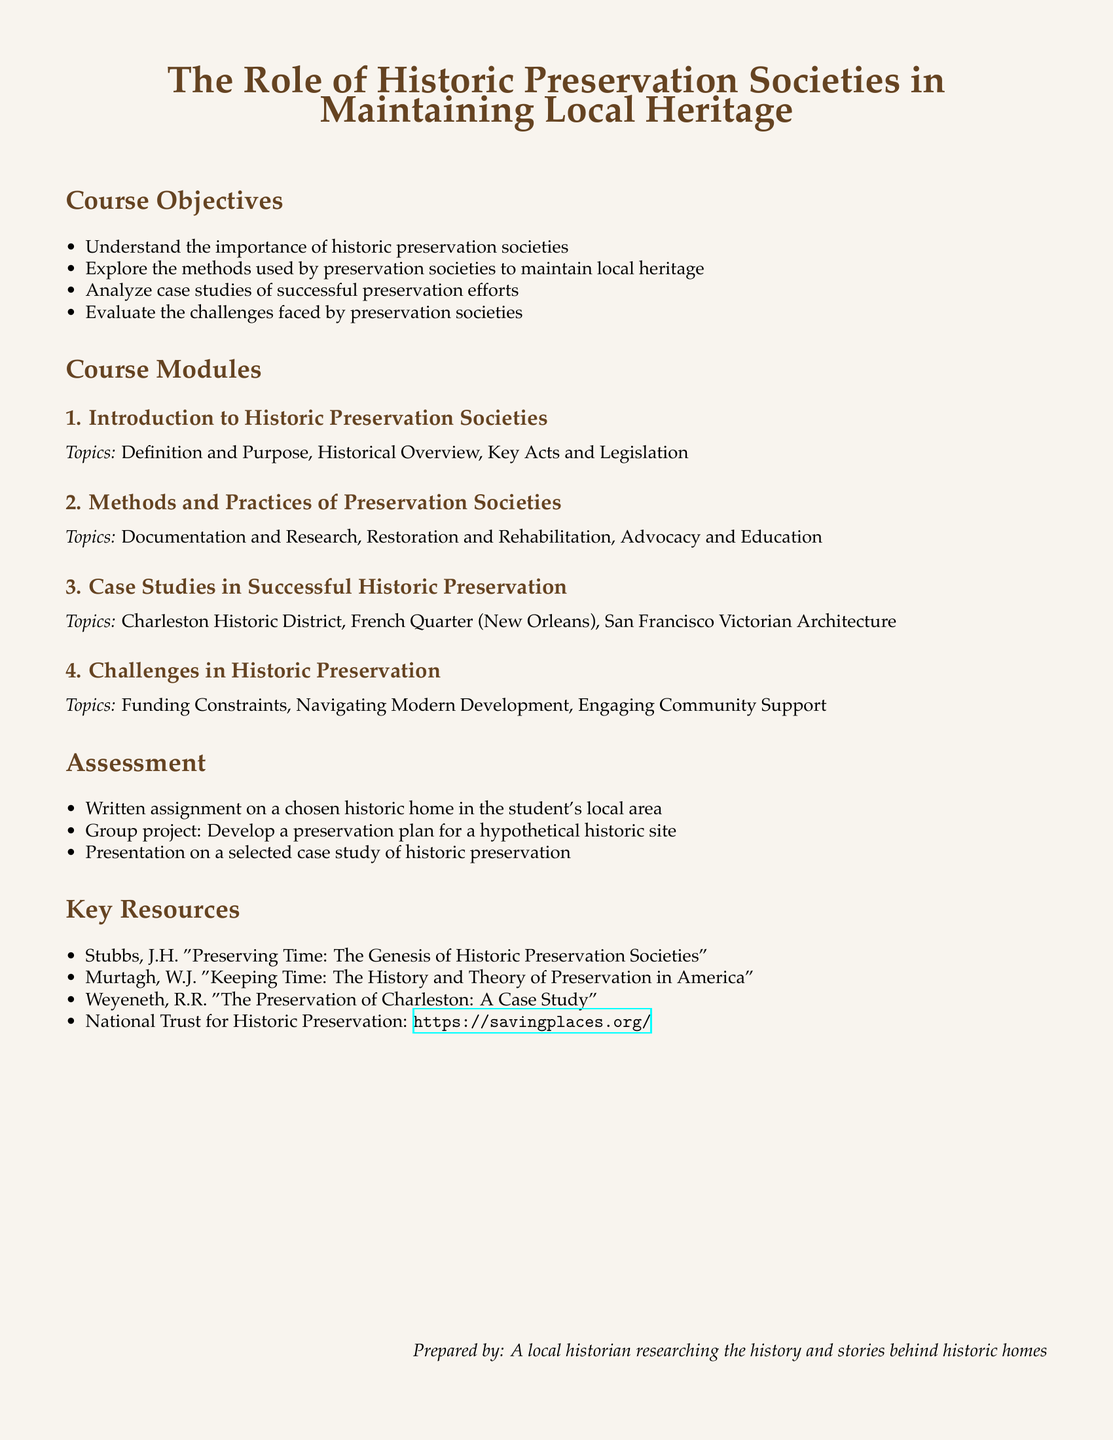what is the title of the syllabus? The title of the syllabus is prominently displayed at the top of the document.
Answer: The Role of Historic Preservation Societies in Maintaining Local Heritage what is the first module listed in the course? The first module is listed in the 'Course Modules' section at the beginning.
Answer: Introduction to Historic Preservation Societies who is the prepared by line attributed to? This line acknowledges the author of the document and is found at the bottom of the document.
Answer: A local historian researching the history and stories behind historic homes how many assessment items are listed in the document? The assessment section outlines the items that will be graded, and the total count can be determined by listing them.
Answer: 3 what is the focus of the second course module? The topics covered in the second module are specified after its title.
Answer: Methods and Practices of Preservation Societies name a case study mentioned in the course. The case studies are listed under the third module, and you can cite any one of them.
Answer: Charleston Historic District what is the color used for the header text? The document specifies the colors used for different sections, including the header text.
Answer: darkbrown what is the primary method of evaluation for students? The assessment section details the types of evaluation used in the course.
Answer: Written assignment on a chosen historic home in the student's local area 